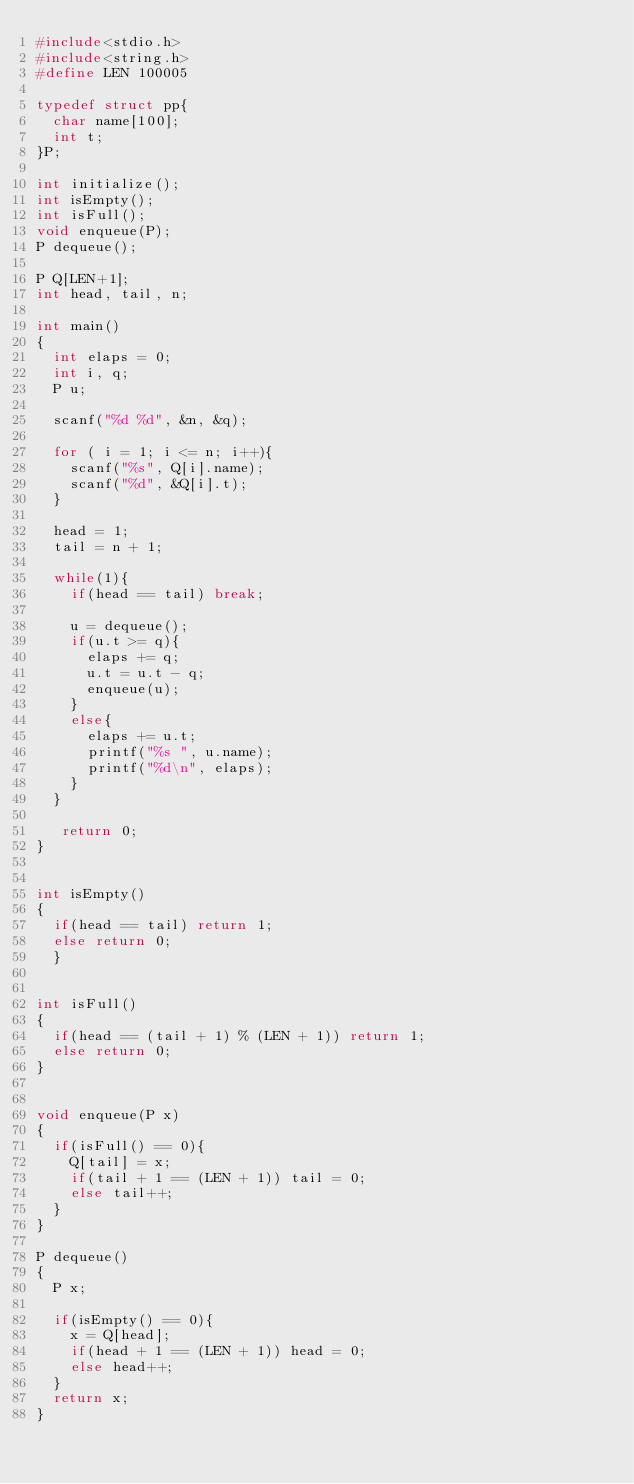Convert code to text. <code><loc_0><loc_0><loc_500><loc_500><_C_>#include<stdio.h>
#include<string.h>
#define LEN 100005

typedef struct pp{
  char name[100];
  int t;
}P;

int initialize();
int isEmpty();
int isFull();
void enqueue(P);
P dequeue();

P Q[LEN+1];
int head, tail, n;

int main()
{
  int elaps = 0;
  int i, q;
  P u;

  scanf("%d %d", &n, &q);

  for ( i = 1; i <= n; i++){
    scanf("%s", Q[i].name);
    scanf("%d", &Q[i].t);
  }

  head = 1;
  tail = n + 1;

  while(1){
    if(head == tail) break;

    u = dequeue();
    if(u.t >= q){
      elaps += q;
      u.t = u.t - q;
      enqueue(u);
    }
    else{
      elaps += u.t;
      printf("%s ", u.name);
      printf("%d\n", elaps);
    }
  }
   
   return 0;
}


int isEmpty()
{
  if(head == tail) return 1;
  else return 0;
  }


int isFull()
{
  if(head == (tail + 1) % (LEN + 1)) return 1;
  else return 0;
}


void enqueue(P x)
{
  if(isFull() == 0){
    Q[tail] = x;
    if(tail + 1 == (LEN + 1)) tail = 0;
    else tail++;
  }
}

P dequeue()
{
  P x;

  if(isEmpty() == 0){
    x = Q[head];
    if(head + 1 == (LEN + 1)) head = 0;
    else head++;
  }
  return x;
}</code> 